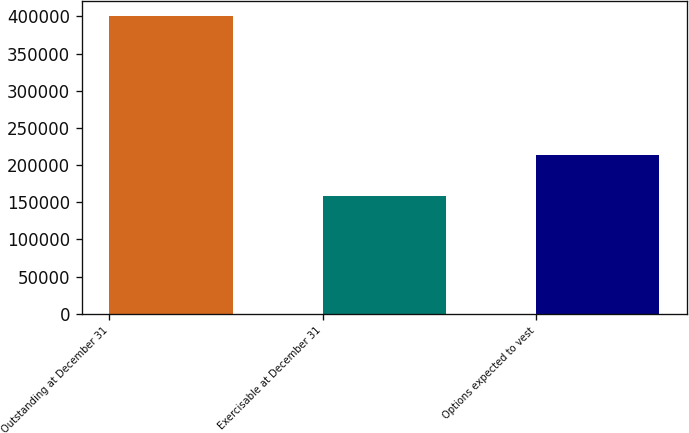Convert chart. <chart><loc_0><loc_0><loc_500><loc_500><bar_chart><fcel>Outstanding at December 31<fcel>Exercisable at December 31<fcel>Options expected to vest<nl><fcel>400439<fcel>158287<fcel>213267<nl></chart> 